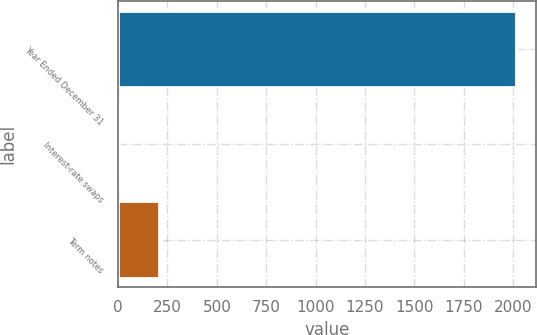Convert chart. <chart><loc_0><loc_0><loc_500><loc_500><bar_chart><fcel>Year Ended December 31<fcel>Interest-rate swaps<fcel>Term notes<nl><fcel>2016<fcel>5.5<fcel>206.55<nl></chart> 